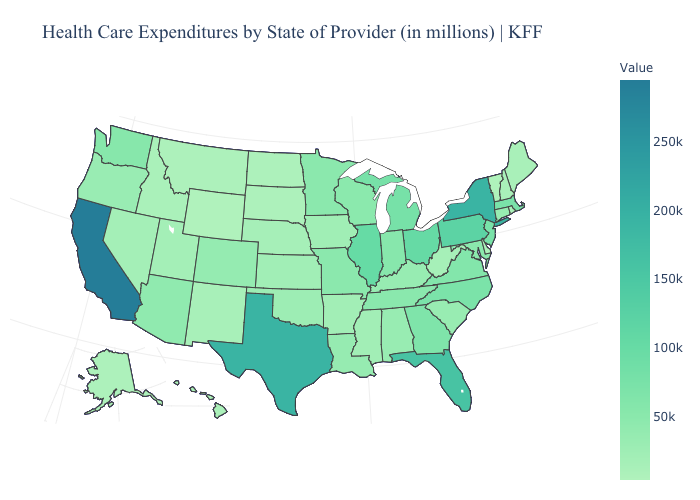Does Arkansas have the lowest value in the South?
Short answer required. No. Among the states that border Nebraska , which have the highest value?
Concise answer only. Missouri. Does the map have missing data?
Short answer required. No. Does California have the highest value in the USA?
Quick response, please. Yes. 